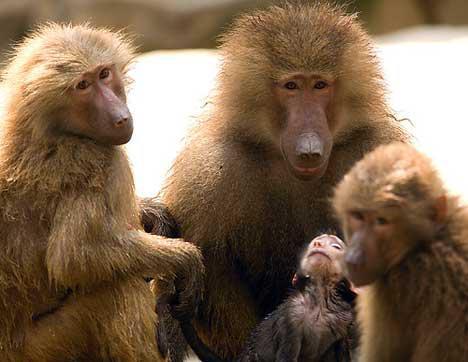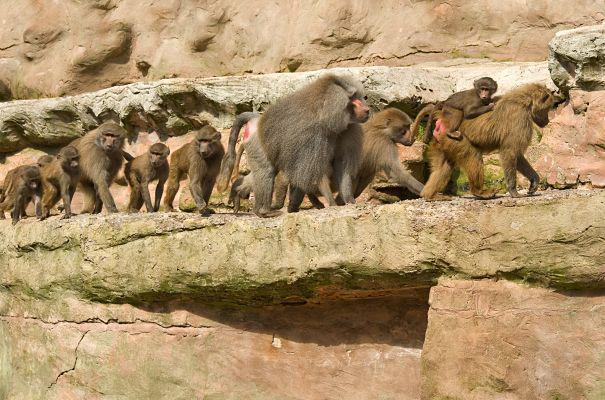The first image is the image on the left, the second image is the image on the right. Analyze the images presented: Is the assertion "There are no more than half a dozen primates in the image on the left." valid? Answer yes or no. Yes. The first image is the image on the left, the second image is the image on the right. Assess this claim about the two images: "Baboons are mostly walking in one direction, in one image.". Correct or not? Answer yes or no. Yes. 